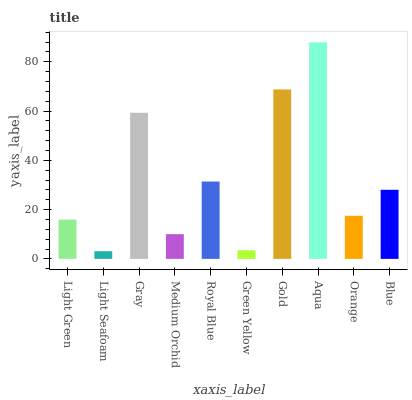Is Light Seafoam the minimum?
Answer yes or no. Yes. Is Aqua the maximum?
Answer yes or no. Yes. Is Gray the minimum?
Answer yes or no. No. Is Gray the maximum?
Answer yes or no. No. Is Gray greater than Light Seafoam?
Answer yes or no. Yes. Is Light Seafoam less than Gray?
Answer yes or no. Yes. Is Light Seafoam greater than Gray?
Answer yes or no. No. Is Gray less than Light Seafoam?
Answer yes or no. No. Is Blue the high median?
Answer yes or no. Yes. Is Orange the low median?
Answer yes or no. Yes. Is Green Yellow the high median?
Answer yes or no. No. Is Light Seafoam the low median?
Answer yes or no. No. 